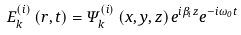<formula> <loc_0><loc_0><loc_500><loc_500>E _ { k } ^ { ( i ) } \left ( r , t \right ) = \Psi _ { k } ^ { ( i ) } \left ( x , y , z \right ) e ^ { i \beta _ { i } z } e ^ { - i \omega _ { 0 } t }</formula> 